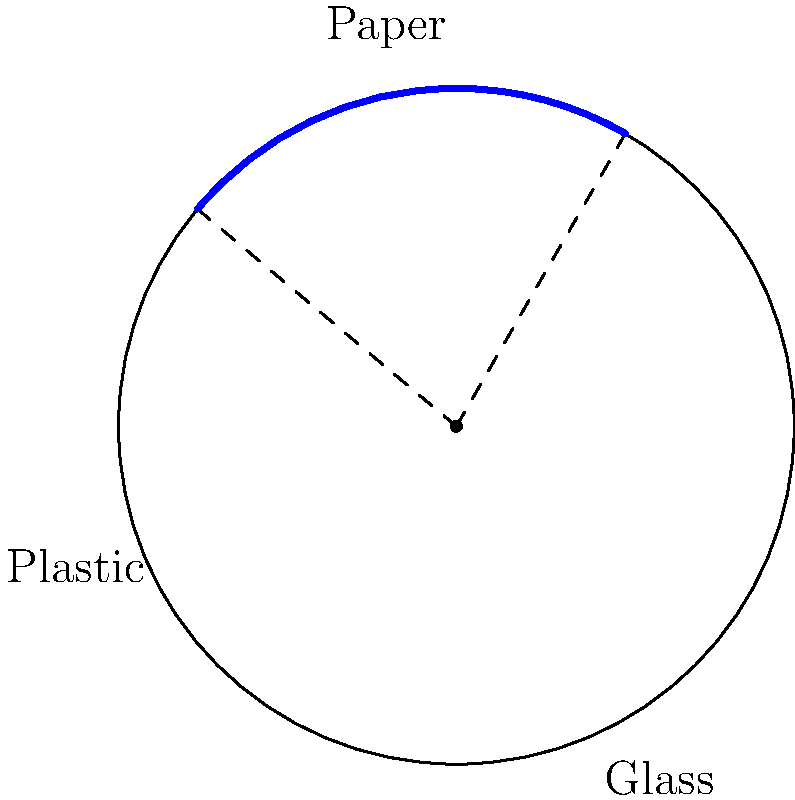In a pie chart representing the distribution of recyclable materials at your facility, the sector for paper waste spans an arc of 80°. If the radius of the chart is 5 meters, what is the area of the sector representing paper waste? Round your answer to two decimal places. To find the area of a sector in a circle, we can use the formula:

$$A = \frac{\theta}{360°} \pi r^2$$

Where:
$A$ = Area of the sector
$\theta$ = Central angle in degrees
$r$ = Radius of the circle

Given:
$\theta = 80°$
$r = 5$ meters

Let's substitute these values into the formula:

$$A = \frac{80°}{360°} \pi (5m)^2$$

Simplifying:
$$A = \frac{2}{9} \pi (25m^2)$$
$$A = \frac{50\pi}{9} m^2$$

Using $\pi \approx 3.14159$:

$$A \approx \frac{50 * 3.14159}{9} m^2$$
$$A \approx 17.45 m^2$$

Rounding to two decimal places:
$$A \approx 17.45 m^2$$
Answer: 17.45 m² 